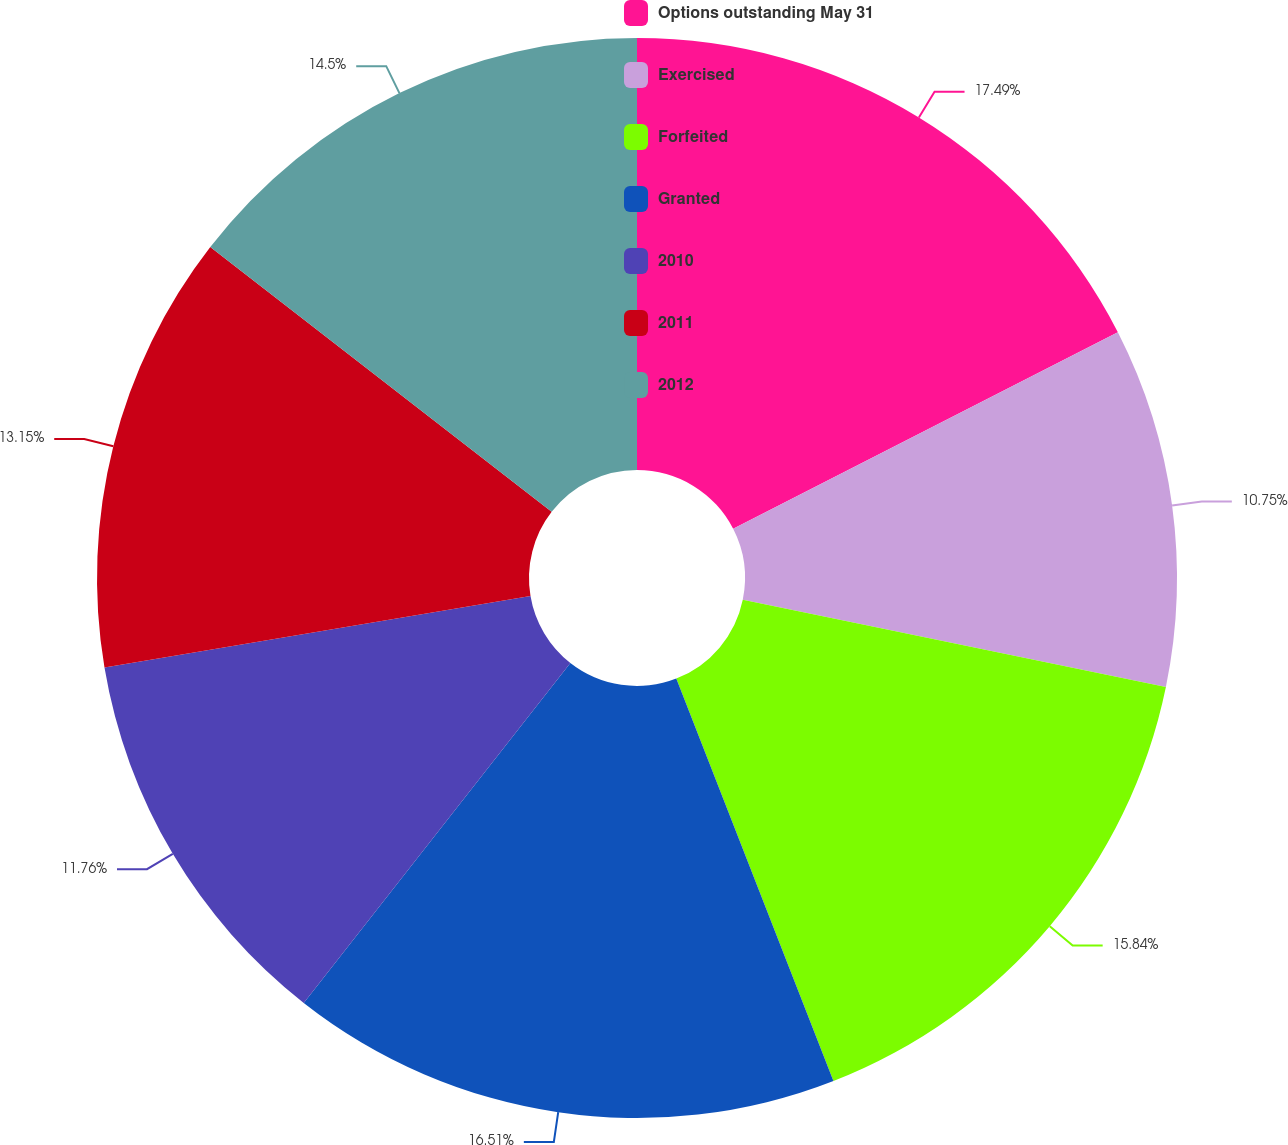Convert chart. <chart><loc_0><loc_0><loc_500><loc_500><pie_chart><fcel>Options outstanding May 31<fcel>Exercised<fcel>Forfeited<fcel>Granted<fcel>2010<fcel>2011<fcel>2012<nl><fcel>17.48%<fcel>10.75%<fcel>15.84%<fcel>16.51%<fcel>11.76%<fcel>13.15%<fcel>14.5%<nl></chart> 